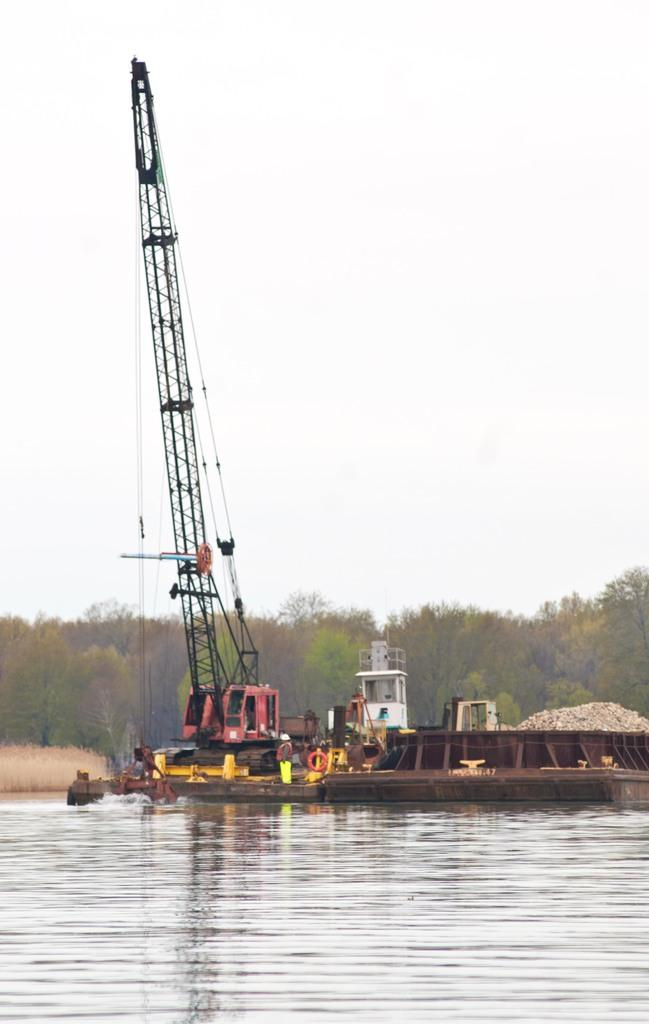What body of water is present in the image? There is a lake in the image. What type of vehicles are in the image? There are crane vessels in the image. How are the vessels positioned in relation to the lake? The vessels are floating on the lake. What are the vessels doing in the image? The vessels are lifting heavy loads. What can be seen in the sky in the image? There is a sky visible in the image. What type of vegetation is present in the image? There are trees in the image. What time of day is it in the image, and what record is being broken by the crane vessels? The time of day and any records being broken are not mentioned in the image. The image only shows crane vessels lifting heavy loads on a lake, with trees and sky visible in the background. 